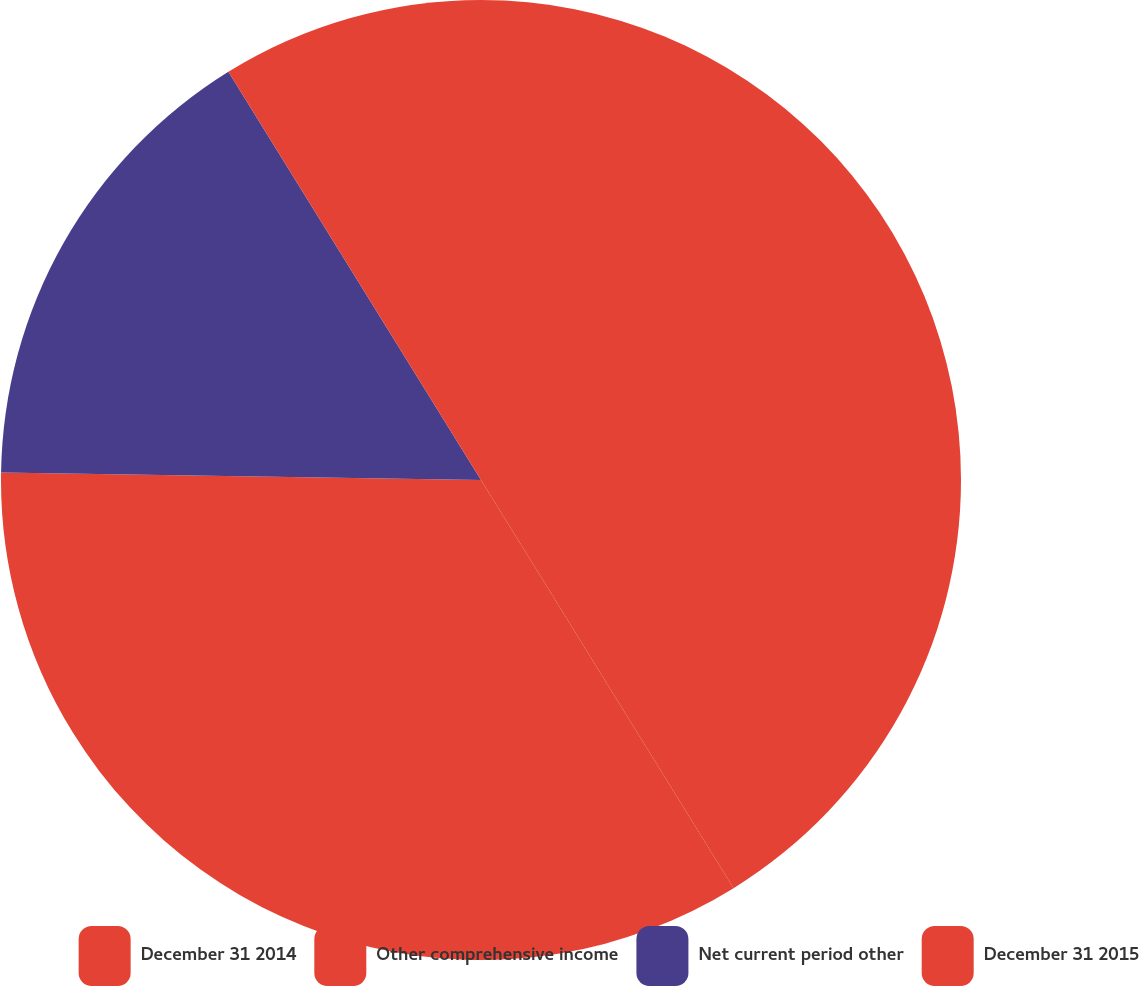Convert chart. <chart><loc_0><loc_0><loc_500><loc_500><pie_chart><fcel>December 31 2014<fcel>Other comprehensive income<fcel>Net current period other<fcel>December 31 2015<nl><fcel>41.18%<fcel>34.07%<fcel>15.93%<fcel>8.82%<nl></chart> 